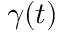<formula> <loc_0><loc_0><loc_500><loc_500>\gamma ( t )</formula> 